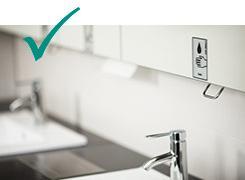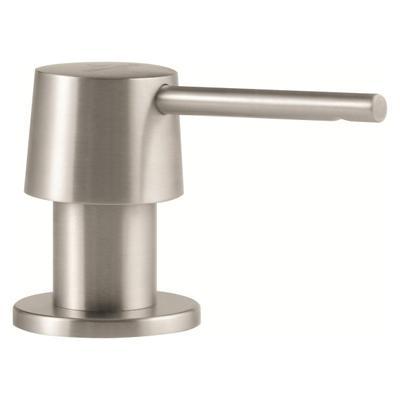The first image is the image on the left, the second image is the image on the right. Assess this claim about the two images: "An image includes a single chrome spout that curves downward.". Correct or not? Answer yes or no. No. 